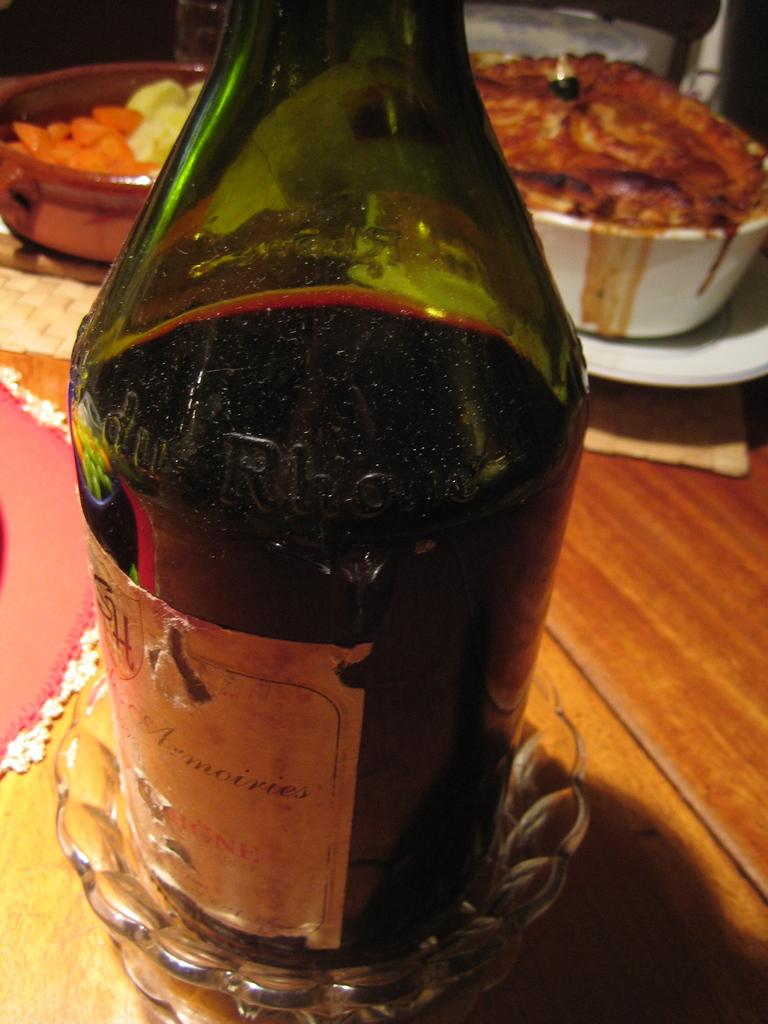What piece of furniture is present in the image? There is a table in the image. What object can be seen on the table? There is a bottle on the table. What type of dishware is on the table? There are bowls on the table. What items are used for decoration or protection on the table? There are placemats on the table. What items are used for cleaning or wiping on the table? There are napkins on the table. What is placed on the table for consumption? There is food placed on the table. What type of tin can be seen in the image? There is no tin present in the image. What type of magic is being performed in the image? There is no magic or magical activity depicted in the image. 